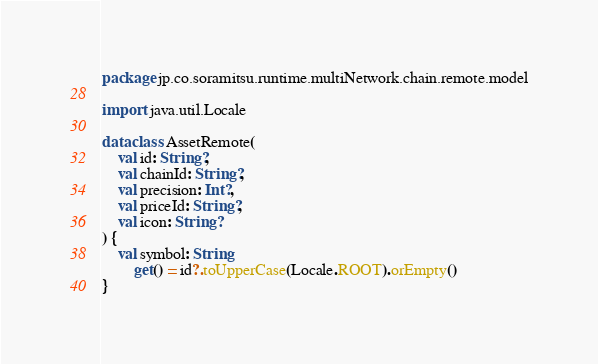Convert code to text. <code><loc_0><loc_0><loc_500><loc_500><_Kotlin_>package jp.co.soramitsu.runtime.multiNetwork.chain.remote.model

import java.util.Locale

data class AssetRemote(
    val id: String?,
    val chainId: String?,
    val precision: Int?,
    val priceId: String?,
    val icon: String?
) {
    val symbol: String
        get() = id?.toUpperCase(Locale.ROOT).orEmpty()
}
</code> 